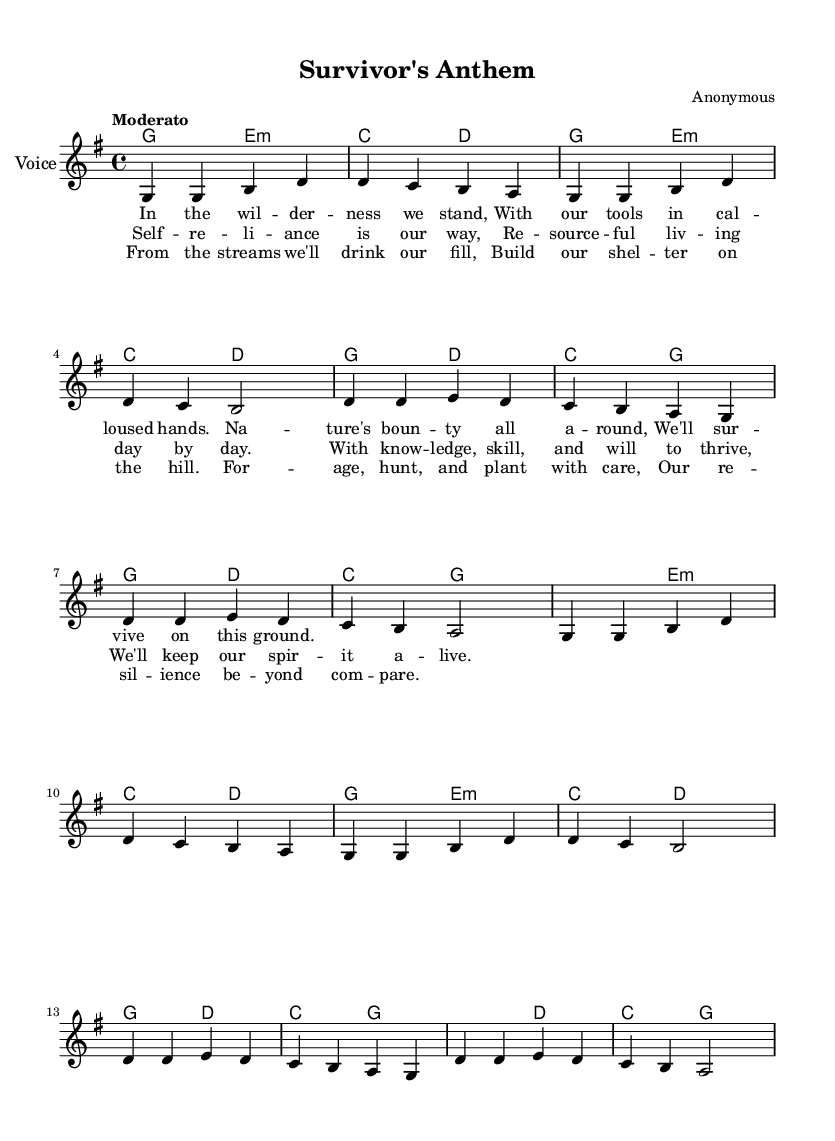what is the key signature of this music? The key signature indicates G major, which has one sharp, F sharp. This is determined by the 'g \major' instruction in the global settings of the code.
Answer: G major what is the time signature of the piece? The time signature is stated as 4/4, shown in the 'time 4/4' line of the global settings. This means there are four beats in each measure, and a quarter note gets one beat.
Answer: 4/4 what is the tempo marking for the piece? The tempo marking is "Moderato," specified by the 'tempo "Moderato"' line in the global settings. This indicates a moderate pace for the performance of the piece.
Answer: Moderato how many verses are there in the song? The lyrics section includes two verses labeled as 'verseOne' and 'verseTwo,' which indicates that there are two sections of lyrics that can be classified as verses.
Answer: Two what is the main theme of the lyrics? The lyrics celebrate self-reliance and resourcefulness, discussing living in harmony with nature and thriving through knowledge and skills. This theme is reflected throughout the lyrics, such as "Self-reliance is our way" in the chorus.
Answer: Self-reliance how many measures are in the chorus section? The chorus is made up of four measures, as indicated by the repeated musical phrases in the melody notation during the chorus section (all labeled under 'chorus').
Answer: Four which musical forms can be identified in this piece? This piece combines verse and chorus structures, as seen in the alternation of 'verseOne' and 'verseTwo' with the 'chorus' section in between. This format is traditional in folk songs and supports the storytelling aspect.
Answer: Verse-Chorus 